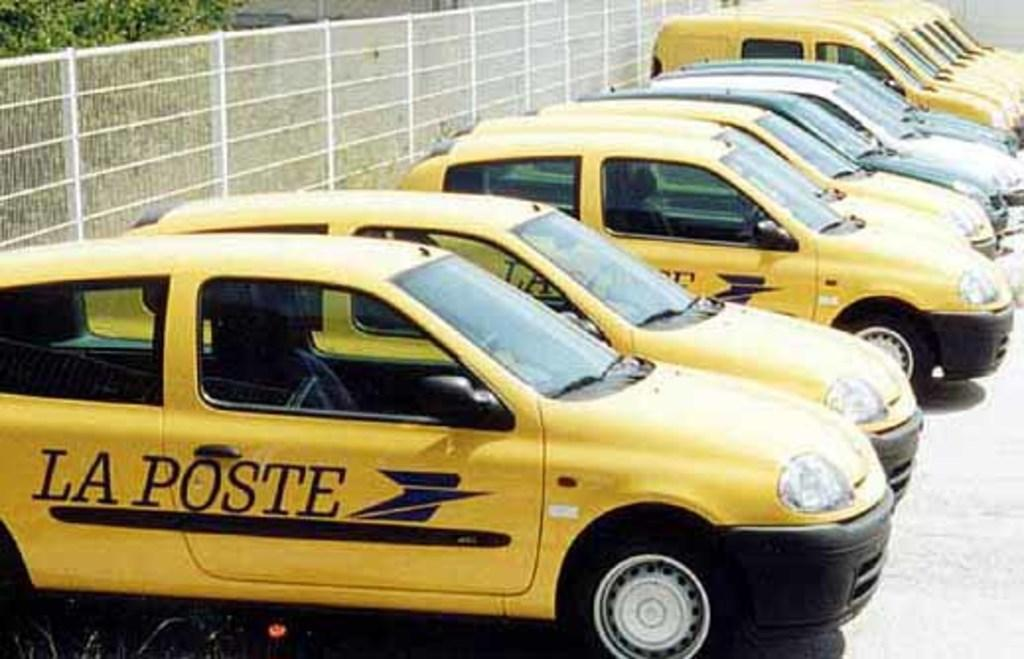What can be seen in a row in the image? There are cars placed in a row in the image. What is at the bottom of the image? There is a road at the bottom of the image. What is visible in the background of the image? There is a fence and trees in the background of the image. Can you see any goldfish swimming in the image? No, there are no goldfish present in the image. What type of sack is being used to fold the cars in the image? There is no sack or folding of cars in the image; the cars are simply parked in a row. 